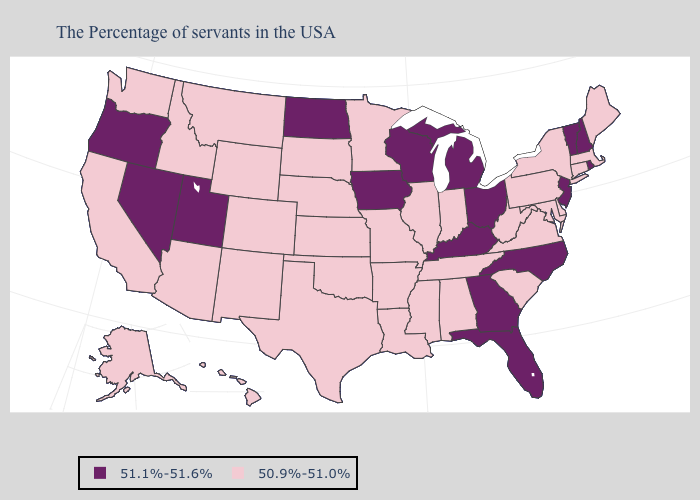Does Iowa have the lowest value in the USA?
Keep it brief. No. Does Montana have the highest value in the West?
Keep it brief. No. Does North Dakota have a higher value than Kentucky?
Short answer required. No. Name the states that have a value in the range 50.9%-51.0%?
Give a very brief answer. Maine, Massachusetts, Connecticut, New York, Delaware, Maryland, Pennsylvania, Virginia, South Carolina, West Virginia, Indiana, Alabama, Tennessee, Illinois, Mississippi, Louisiana, Missouri, Arkansas, Minnesota, Kansas, Nebraska, Oklahoma, Texas, South Dakota, Wyoming, Colorado, New Mexico, Montana, Arizona, Idaho, California, Washington, Alaska, Hawaii. Does Massachusetts have the lowest value in the Northeast?
Short answer required. Yes. Name the states that have a value in the range 50.9%-51.0%?
Write a very short answer. Maine, Massachusetts, Connecticut, New York, Delaware, Maryland, Pennsylvania, Virginia, South Carolina, West Virginia, Indiana, Alabama, Tennessee, Illinois, Mississippi, Louisiana, Missouri, Arkansas, Minnesota, Kansas, Nebraska, Oklahoma, Texas, South Dakota, Wyoming, Colorado, New Mexico, Montana, Arizona, Idaho, California, Washington, Alaska, Hawaii. Name the states that have a value in the range 50.9%-51.0%?
Short answer required. Maine, Massachusetts, Connecticut, New York, Delaware, Maryland, Pennsylvania, Virginia, South Carolina, West Virginia, Indiana, Alabama, Tennessee, Illinois, Mississippi, Louisiana, Missouri, Arkansas, Minnesota, Kansas, Nebraska, Oklahoma, Texas, South Dakota, Wyoming, Colorado, New Mexico, Montana, Arizona, Idaho, California, Washington, Alaska, Hawaii. Does Georgia have the lowest value in the South?
Be succinct. No. What is the value of Kentucky?
Short answer required. 51.1%-51.6%. Name the states that have a value in the range 50.9%-51.0%?
Quick response, please. Maine, Massachusetts, Connecticut, New York, Delaware, Maryland, Pennsylvania, Virginia, South Carolina, West Virginia, Indiana, Alabama, Tennessee, Illinois, Mississippi, Louisiana, Missouri, Arkansas, Minnesota, Kansas, Nebraska, Oklahoma, Texas, South Dakota, Wyoming, Colorado, New Mexico, Montana, Arizona, Idaho, California, Washington, Alaska, Hawaii. What is the lowest value in states that border South Carolina?
Keep it brief. 51.1%-51.6%. Does Utah have the highest value in the USA?
Concise answer only. Yes. Name the states that have a value in the range 50.9%-51.0%?
Be succinct. Maine, Massachusetts, Connecticut, New York, Delaware, Maryland, Pennsylvania, Virginia, South Carolina, West Virginia, Indiana, Alabama, Tennessee, Illinois, Mississippi, Louisiana, Missouri, Arkansas, Minnesota, Kansas, Nebraska, Oklahoma, Texas, South Dakota, Wyoming, Colorado, New Mexico, Montana, Arizona, Idaho, California, Washington, Alaska, Hawaii. What is the highest value in the MidWest ?
Answer briefly. 51.1%-51.6%. 